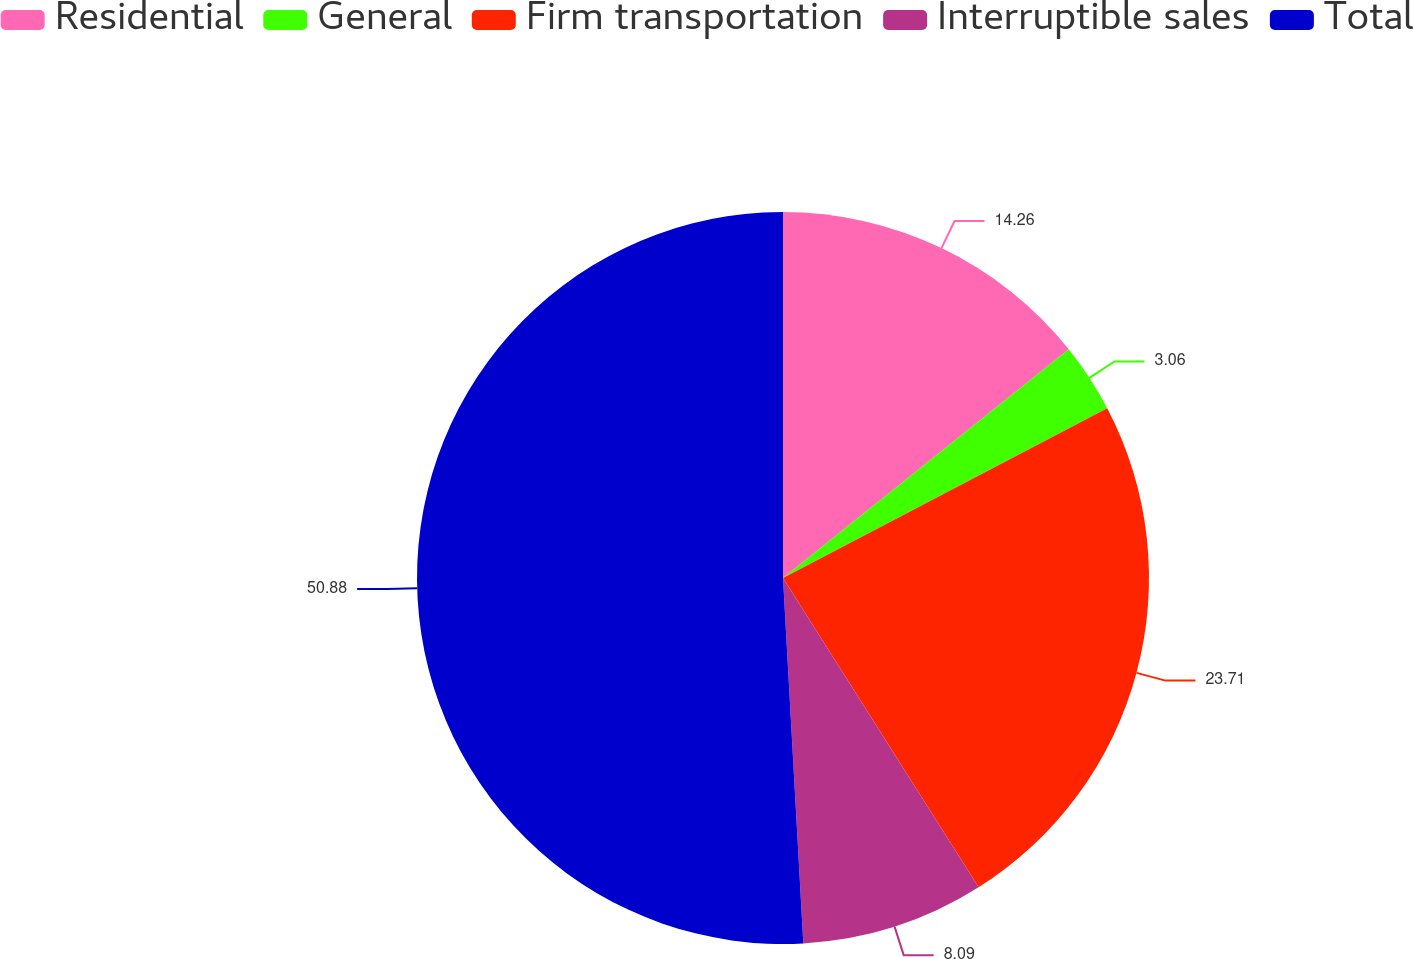<chart> <loc_0><loc_0><loc_500><loc_500><pie_chart><fcel>Residential<fcel>General<fcel>Firm transportation<fcel>Interruptible sales<fcel>Total<nl><fcel>14.26%<fcel>3.06%<fcel>23.71%<fcel>8.09%<fcel>50.89%<nl></chart> 